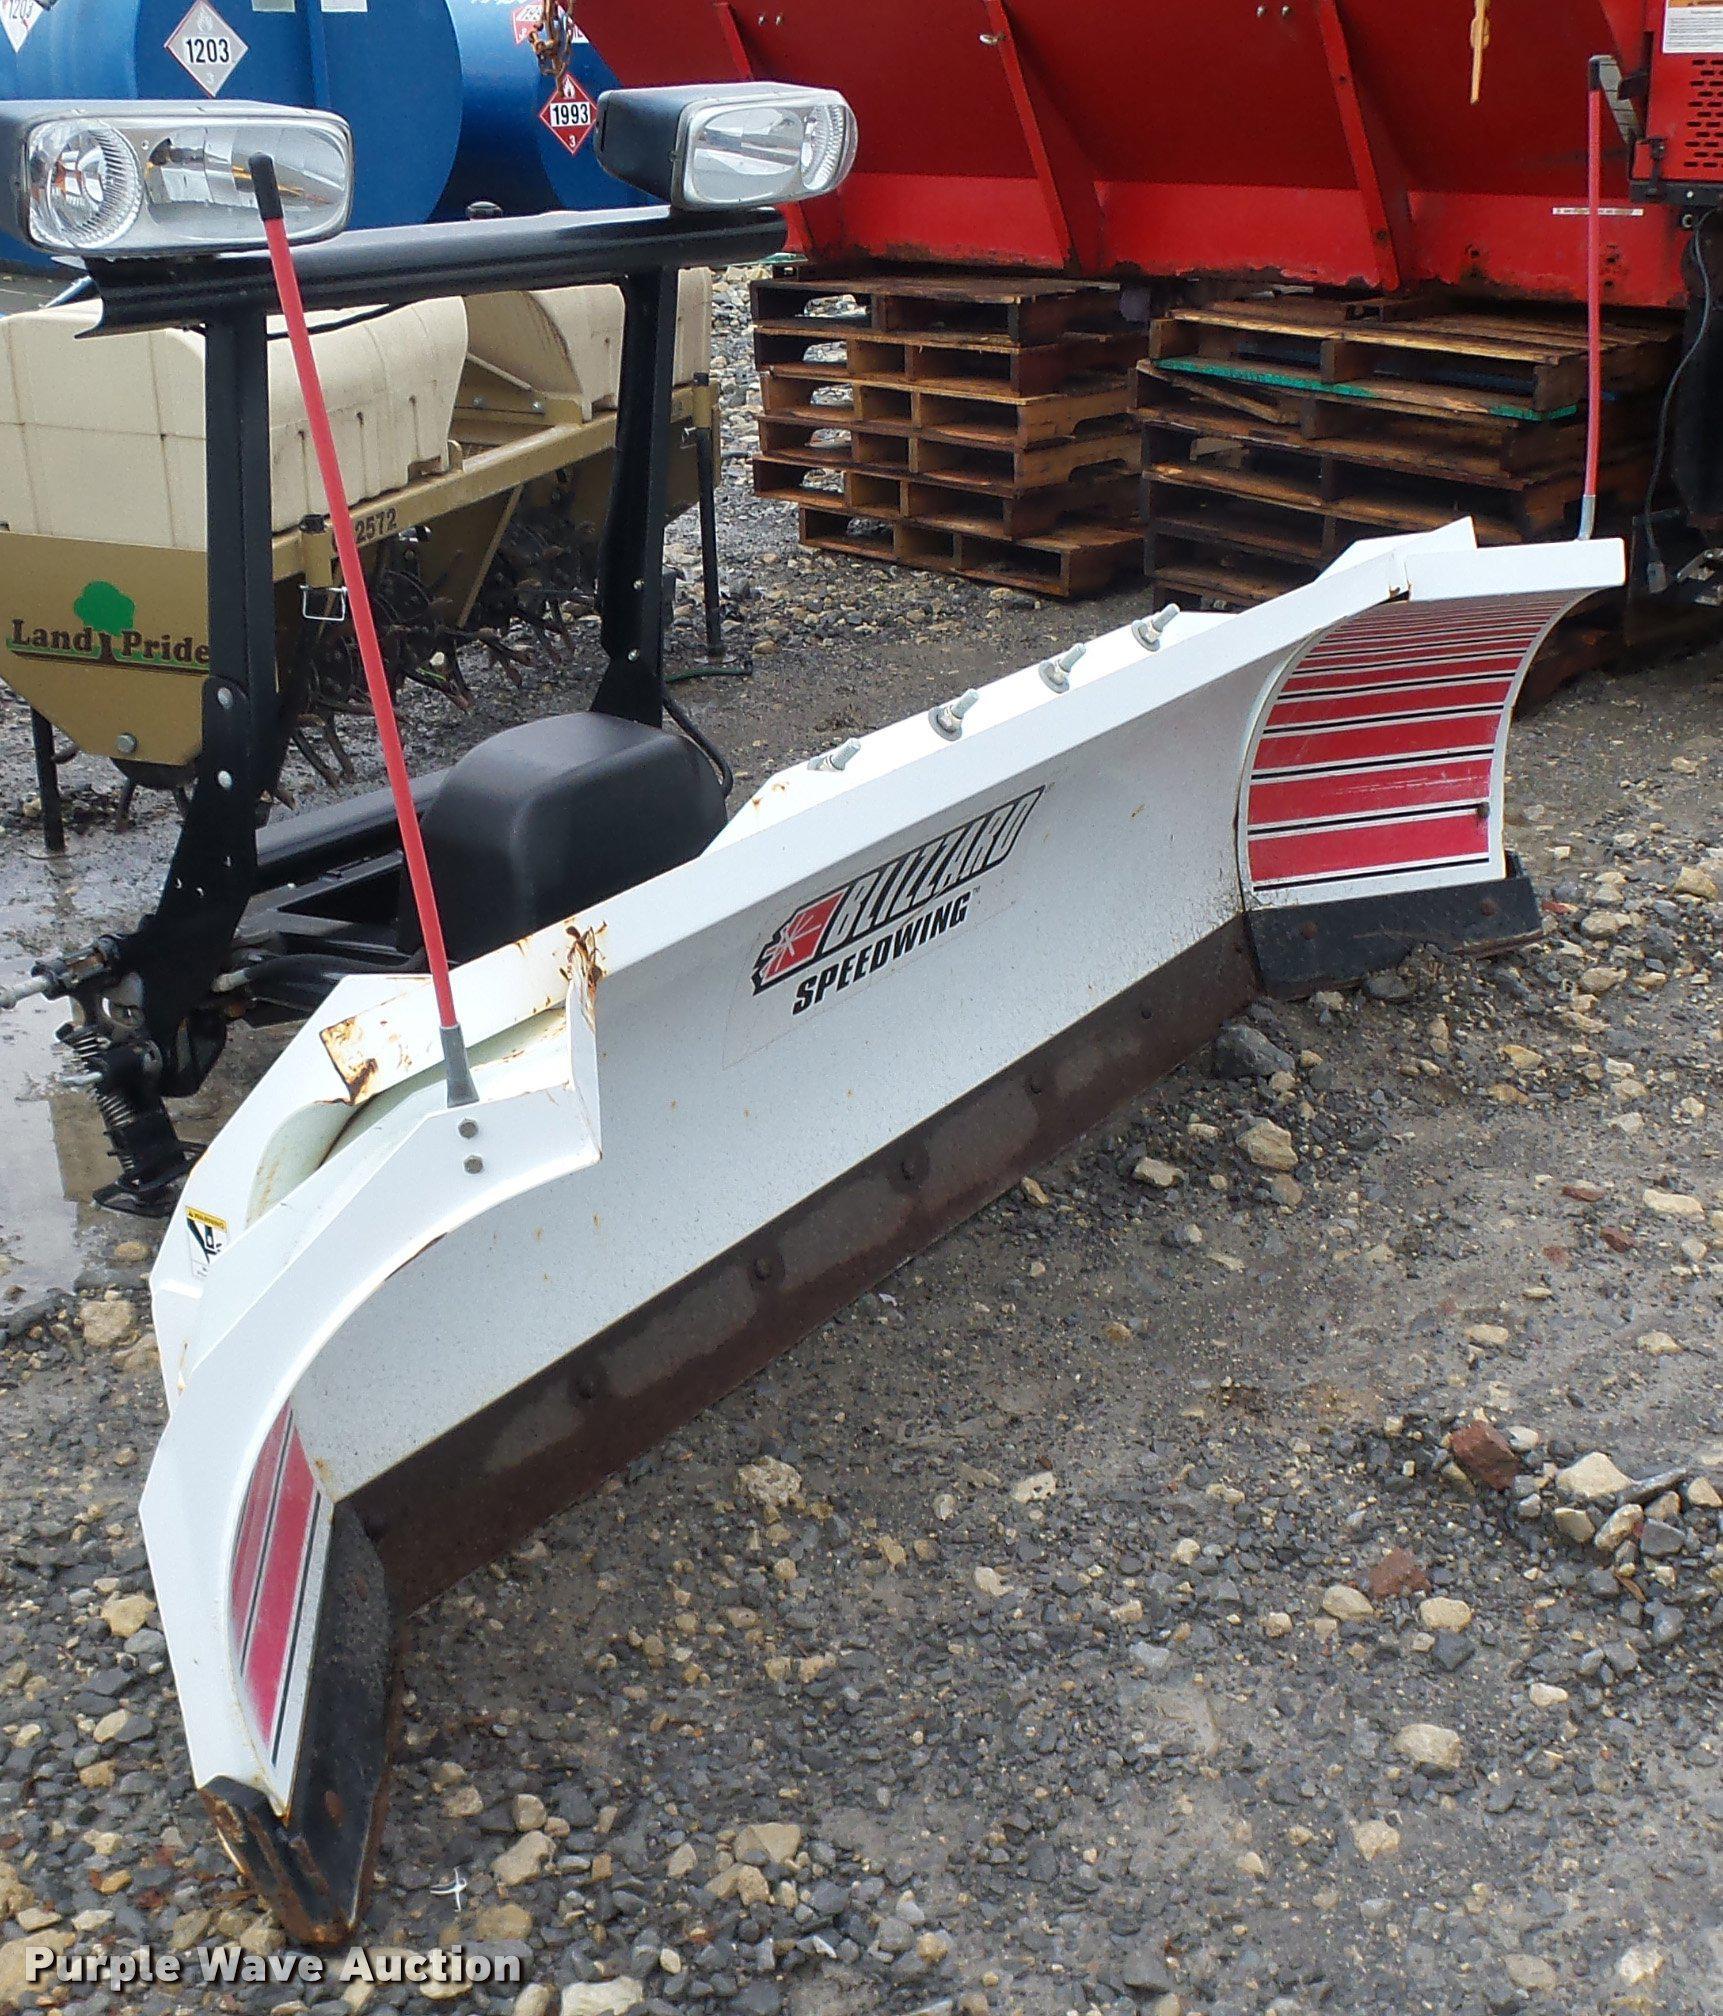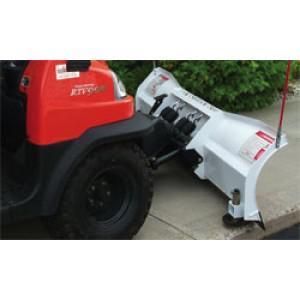The first image is the image on the left, the second image is the image on the right. Given the left and right images, does the statement "One image shows a vehicle pushing a plow through snow." hold true? Answer yes or no. No. The first image is the image on the left, the second image is the image on the right. For the images shown, is this caption "Snow is being cleared by a vehicle." true? Answer yes or no. No. 